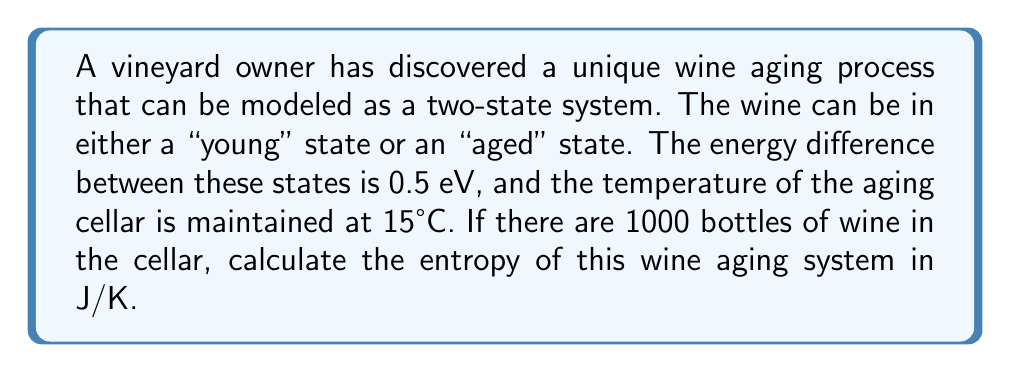Help me with this question. To solve this problem, we'll use principles of statistical mechanics:

1. Convert temperature to Kelvin:
   $T = 15°C + 273.15 = 288.15 K$

2. Convert energy difference to Joules:
   $\Delta E = 0.5 \text{ eV} \times 1.602 \times 10^{-19} \text{ J/eV} = 8.01 \times 10^{-20} \text{ J}$

3. Calculate the partition function Z:
   $$Z = e^{-E_1/kT} + e^{-E_2/kT} = 1 + e^{-\Delta E/kT}$$
   where $k$ is the Boltzmann constant ($1.380649 \times 10^{-23} \text{ J/K}$)

4. Calculate Z:
   $$Z = 1 + e^{-(8.01 \times 10^{-20}) / (1.380649 \times 10^{-23} \times 288.15)} = 1 + e^{-20.11} = 1.000000002$$

5. Calculate the probabilities of each state:
   $$p_1 = \frac{1}{Z} = 0.999999998$$
   $$p_2 = \frac{e^{-\Delta E/kT}}{Z} = 0.000000002$$

6. Calculate the entropy for a single bottle:
   $$S = -k(p_1 \ln p_1 + p_2 \ln p_2)$$
   $$S = -1.380649 \times 10^{-23} \times (-4.60517 \times 10^{-9}) = 6.358 \times 10^{-32} \text{ J/K}$$

7. For 1000 bottles, multiply the single bottle entropy by 1000:
   $$S_{total} = 1000 \times 6.358 \times 10^{-32} = 6.358 \times 10^{-29} \text{ J/K}$$
Answer: $6.358 \times 10^{-29} \text{ J/K}$ 